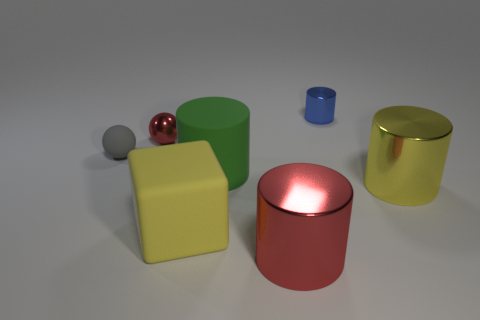Add 3 yellow blocks. How many objects exist? 10 Subtract all cylinders. How many objects are left? 3 Add 6 cylinders. How many cylinders exist? 10 Subtract 0 brown cylinders. How many objects are left? 7 Subtract all green rubber things. Subtract all gray things. How many objects are left? 5 Add 5 small red metallic balls. How many small red metallic balls are left? 6 